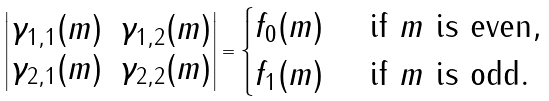<formula> <loc_0><loc_0><loc_500><loc_500>\begin{vmatrix} \gamma _ { 1 , 1 } ( m ) & \gamma _ { 1 , 2 } ( m ) \\ \gamma _ { 2 , 1 } ( m ) & \gamma _ { 2 , 2 } ( m ) \end{vmatrix} = \begin{cases} f _ { 0 } ( m ) & \text { if $m$ is even} , \\ f _ { 1 } ( m ) & \text { if $m$ is odd} . \end{cases}</formula> 